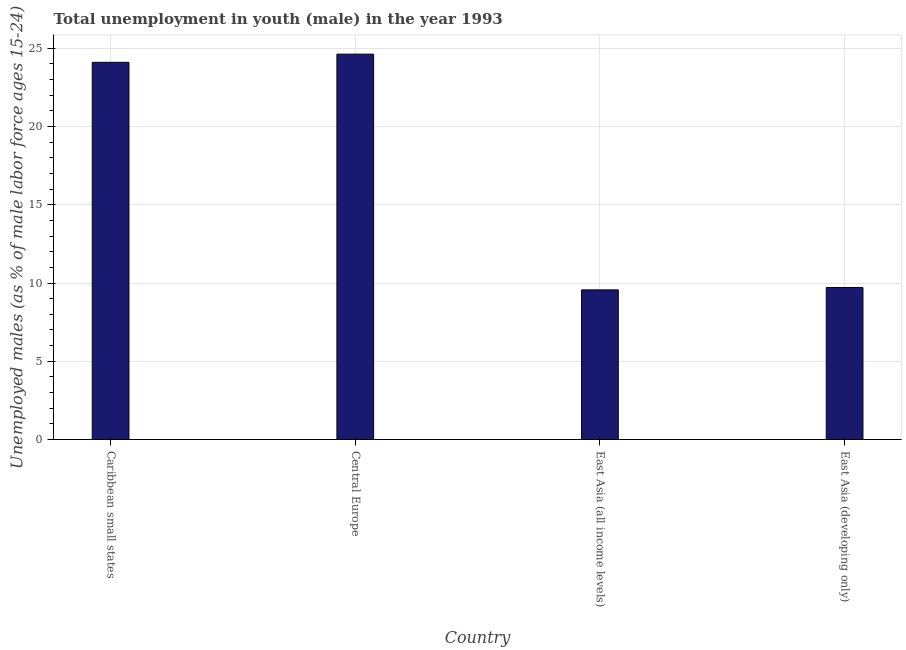What is the title of the graph?
Your answer should be compact. Total unemployment in youth (male) in the year 1993. What is the label or title of the Y-axis?
Ensure brevity in your answer.  Unemployed males (as % of male labor force ages 15-24). What is the unemployed male youth population in Central Europe?
Offer a terse response. 24.62. Across all countries, what is the maximum unemployed male youth population?
Make the answer very short. 24.62. Across all countries, what is the minimum unemployed male youth population?
Your response must be concise. 9.56. In which country was the unemployed male youth population maximum?
Provide a succinct answer. Central Europe. In which country was the unemployed male youth population minimum?
Ensure brevity in your answer.  East Asia (all income levels). What is the sum of the unemployed male youth population?
Ensure brevity in your answer.  67.99. What is the difference between the unemployed male youth population in Caribbean small states and East Asia (all income levels)?
Make the answer very short. 14.54. What is the average unemployed male youth population per country?
Offer a very short reply. 17. What is the median unemployed male youth population?
Provide a succinct answer. 16.91. What is the ratio of the unemployed male youth population in Central Europe to that in East Asia (all income levels)?
Offer a terse response. 2.58. Is the unemployed male youth population in Central Europe less than that in East Asia (all income levels)?
Your answer should be very brief. No. Is the difference between the unemployed male youth population in Central Europe and East Asia (developing only) greater than the difference between any two countries?
Provide a succinct answer. No. What is the difference between the highest and the second highest unemployed male youth population?
Provide a short and direct response. 0.52. What is the difference between the highest and the lowest unemployed male youth population?
Provide a succinct answer. 15.06. In how many countries, is the unemployed male youth population greater than the average unemployed male youth population taken over all countries?
Provide a succinct answer. 2. Are all the bars in the graph horizontal?
Give a very brief answer. No. How many countries are there in the graph?
Provide a short and direct response. 4. What is the Unemployed males (as % of male labor force ages 15-24) of Caribbean small states?
Make the answer very short. 24.1. What is the Unemployed males (as % of male labor force ages 15-24) in Central Europe?
Your response must be concise. 24.62. What is the Unemployed males (as % of male labor force ages 15-24) in East Asia (all income levels)?
Make the answer very short. 9.56. What is the Unemployed males (as % of male labor force ages 15-24) of East Asia (developing only)?
Provide a succinct answer. 9.71. What is the difference between the Unemployed males (as % of male labor force ages 15-24) in Caribbean small states and Central Europe?
Your answer should be very brief. -0.52. What is the difference between the Unemployed males (as % of male labor force ages 15-24) in Caribbean small states and East Asia (all income levels)?
Offer a very short reply. 14.54. What is the difference between the Unemployed males (as % of male labor force ages 15-24) in Caribbean small states and East Asia (developing only)?
Keep it short and to the point. 14.39. What is the difference between the Unemployed males (as % of male labor force ages 15-24) in Central Europe and East Asia (all income levels)?
Your answer should be compact. 15.06. What is the difference between the Unemployed males (as % of male labor force ages 15-24) in Central Europe and East Asia (developing only)?
Your response must be concise. 14.91. What is the difference between the Unemployed males (as % of male labor force ages 15-24) in East Asia (all income levels) and East Asia (developing only)?
Provide a short and direct response. -0.15. What is the ratio of the Unemployed males (as % of male labor force ages 15-24) in Caribbean small states to that in East Asia (all income levels)?
Provide a succinct answer. 2.52. What is the ratio of the Unemployed males (as % of male labor force ages 15-24) in Caribbean small states to that in East Asia (developing only)?
Keep it short and to the point. 2.48. What is the ratio of the Unemployed males (as % of male labor force ages 15-24) in Central Europe to that in East Asia (all income levels)?
Provide a succinct answer. 2.58. What is the ratio of the Unemployed males (as % of male labor force ages 15-24) in Central Europe to that in East Asia (developing only)?
Provide a succinct answer. 2.54. 